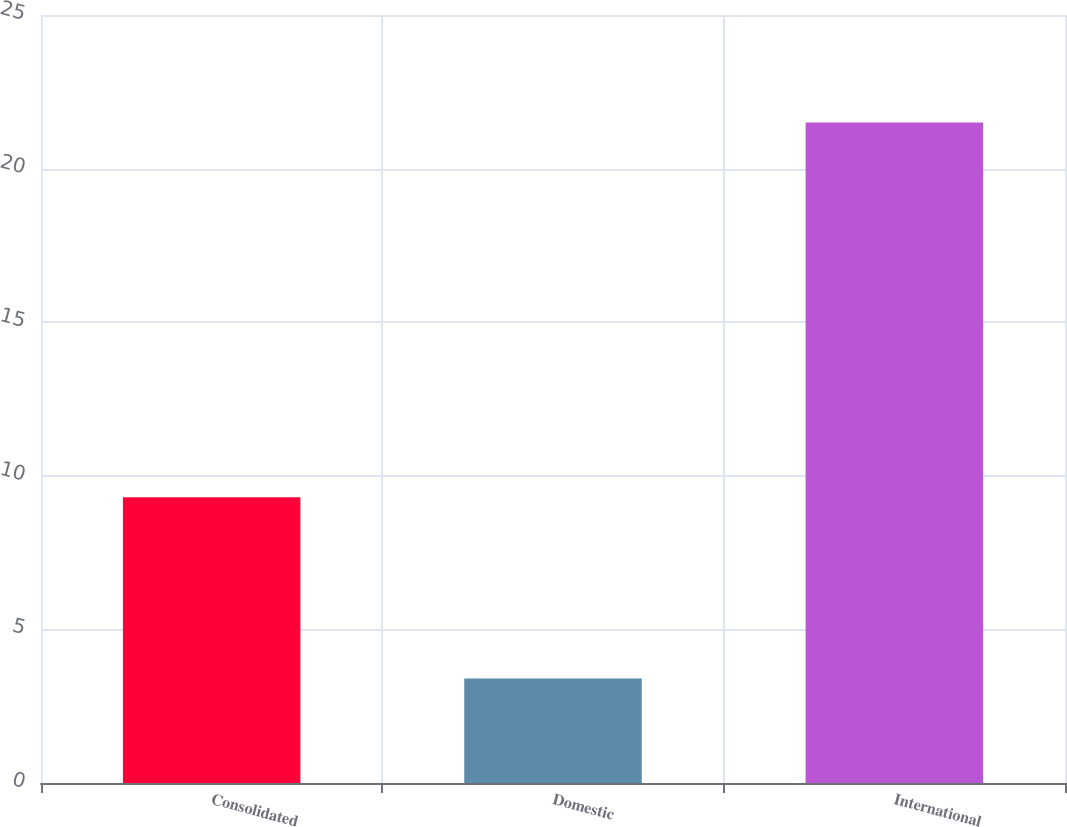Convert chart. <chart><loc_0><loc_0><loc_500><loc_500><bar_chart><fcel>Consolidated<fcel>Domestic<fcel>International<nl><fcel>9.3<fcel>3.4<fcel>21.5<nl></chart> 